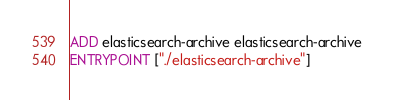<code> <loc_0><loc_0><loc_500><loc_500><_Dockerfile_>
ADD elasticsearch-archive elasticsearch-archive
ENTRYPOINT ["./elasticsearch-archive"]
</code> 